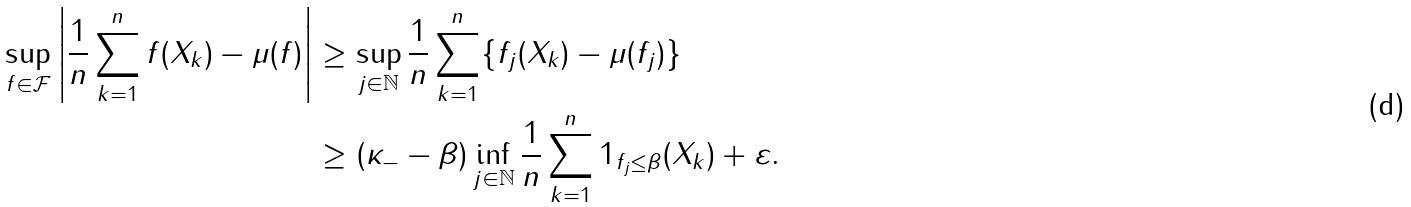Convert formula to latex. <formula><loc_0><loc_0><loc_500><loc_500>\sup _ { f \in \mathcal { F } } \left | \frac { 1 } { n } \sum _ { k = 1 } ^ { n } f ( X _ { k } ) - \mu ( f ) \right | & \geq \sup _ { j \in \mathbb { N } } \frac { 1 } { n } \sum _ { k = 1 } ^ { n } \{ f _ { j } ( X _ { k } ) - \mu ( f _ { j } ) \} \\ & \geq ( \kappa _ { - } - \beta ) \inf _ { j \in \mathbb { N } } \frac { 1 } { n } \sum _ { k = 1 } ^ { n } 1 _ { f _ { j } \leq \beta } ( X _ { k } ) + \varepsilon .</formula> 